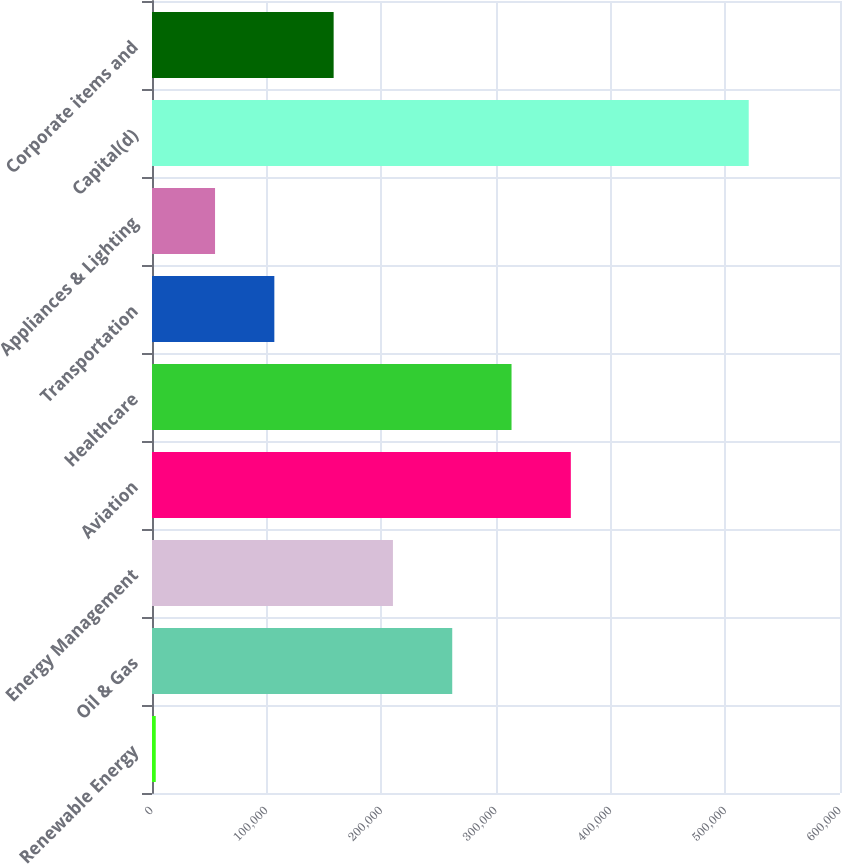Convert chart. <chart><loc_0><loc_0><loc_500><loc_500><bar_chart><fcel>Renewable Energy<fcel>Oil & Gas<fcel>Energy Management<fcel>Aviation<fcel>Healthcare<fcel>Transportation<fcel>Appliances & Lighting<fcel>Capital(d)<fcel>Corporate items and<nl><fcel>3269<fcel>261834<fcel>210121<fcel>365260<fcel>313547<fcel>106695<fcel>54982<fcel>520399<fcel>158408<nl></chart> 